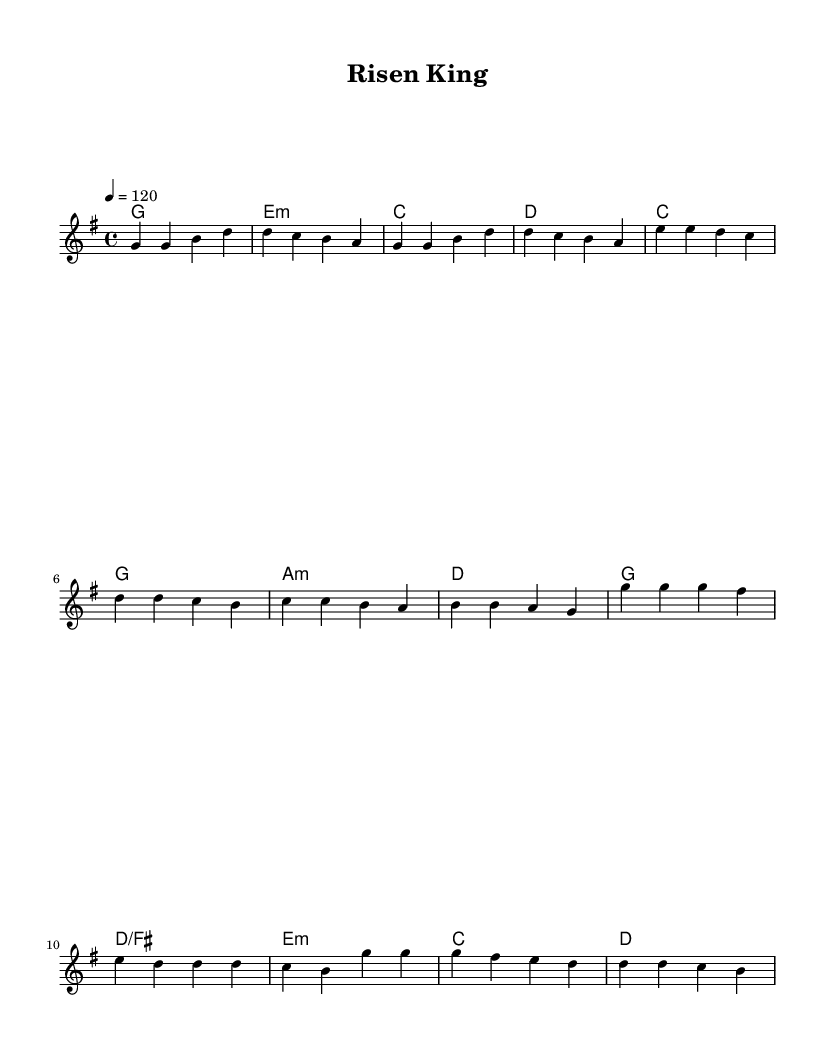What is the time signature of this music? The time signature is indicated at the beginning of the score as 4/4, which means there are four beats in each measure, and a quarter note receives one beat.
Answer: 4/4 What key is this piece in? The key signature is shown at the beginning of the score as G major, which has one sharp (F#).
Answer: G major What is the tempo marking for this piece? The tempo is given in the score as 4 = 120, which indicates that the quarter note should play at 120 beats per minute.
Answer: 120 How many measures are in the Verse section? By counting the measures in the melody section labeled as Verse, there are four measures in total.
Answer: 4 What chord follows the pre-chorus A minor in the harmony? Observing the harmony for the Pre-Chorus, the chord that follows A minor is D major.
Answer: D What is the first note in the Chorus? Looking at the melody for the Chorus section, the first note is G in the octave relative to the lead voice part.
Answer: G What is the overall musical style of this piece? The elements such as the use of powerful male vocals and electronic influences suggest that it falls under contemporary worship music, often characterized by its uplifting and modern sound.
Answer: Contemporary worship 